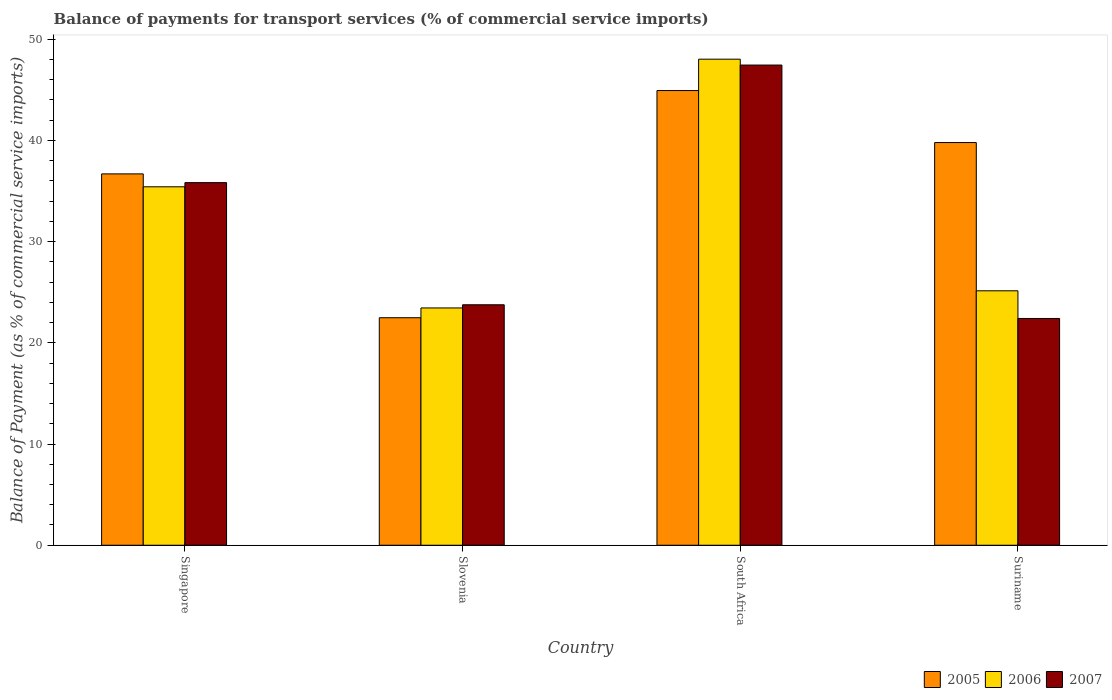How many different coloured bars are there?
Offer a terse response. 3. Are the number of bars per tick equal to the number of legend labels?
Provide a succinct answer. Yes. How many bars are there on the 1st tick from the left?
Your answer should be compact. 3. How many bars are there on the 4th tick from the right?
Provide a succinct answer. 3. What is the label of the 4th group of bars from the left?
Give a very brief answer. Suriname. What is the balance of payments for transport services in 2006 in South Africa?
Provide a short and direct response. 48.03. Across all countries, what is the maximum balance of payments for transport services in 2006?
Give a very brief answer. 48.03. Across all countries, what is the minimum balance of payments for transport services in 2006?
Give a very brief answer. 23.45. In which country was the balance of payments for transport services in 2007 maximum?
Your response must be concise. South Africa. In which country was the balance of payments for transport services in 2007 minimum?
Your answer should be compact. Suriname. What is the total balance of payments for transport services in 2006 in the graph?
Keep it short and to the point. 132.04. What is the difference between the balance of payments for transport services in 2007 in Slovenia and that in Suriname?
Give a very brief answer. 1.35. What is the difference between the balance of payments for transport services in 2006 in Suriname and the balance of payments for transport services in 2005 in Slovenia?
Offer a very short reply. 2.66. What is the average balance of payments for transport services in 2007 per country?
Make the answer very short. 32.36. What is the difference between the balance of payments for transport services of/in 2007 and balance of payments for transport services of/in 2006 in South Africa?
Give a very brief answer. -0.58. What is the ratio of the balance of payments for transport services in 2007 in Singapore to that in Slovenia?
Offer a very short reply. 1.51. Is the balance of payments for transport services in 2007 in South Africa less than that in Suriname?
Keep it short and to the point. No. What is the difference between the highest and the second highest balance of payments for transport services in 2006?
Your response must be concise. 22.89. What is the difference between the highest and the lowest balance of payments for transport services in 2005?
Provide a succinct answer. 22.45. In how many countries, is the balance of payments for transport services in 2005 greater than the average balance of payments for transport services in 2005 taken over all countries?
Your answer should be compact. 3. What does the 1st bar from the left in Suriname represents?
Ensure brevity in your answer.  2005. Is it the case that in every country, the sum of the balance of payments for transport services in 2005 and balance of payments for transport services in 2007 is greater than the balance of payments for transport services in 2006?
Your answer should be compact. Yes. Are the values on the major ticks of Y-axis written in scientific E-notation?
Your answer should be compact. No. Does the graph contain grids?
Keep it short and to the point. No. How many legend labels are there?
Make the answer very short. 3. What is the title of the graph?
Give a very brief answer. Balance of payments for transport services (% of commercial service imports). What is the label or title of the X-axis?
Your answer should be compact. Country. What is the label or title of the Y-axis?
Your answer should be compact. Balance of Payment (as % of commercial service imports). What is the Balance of Payment (as % of commercial service imports) in 2005 in Singapore?
Your answer should be very brief. 36.69. What is the Balance of Payment (as % of commercial service imports) in 2006 in Singapore?
Give a very brief answer. 35.42. What is the Balance of Payment (as % of commercial service imports) in 2007 in Singapore?
Your answer should be very brief. 35.83. What is the Balance of Payment (as % of commercial service imports) in 2005 in Slovenia?
Provide a short and direct response. 22.48. What is the Balance of Payment (as % of commercial service imports) of 2006 in Slovenia?
Your response must be concise. 23.45. What is the Balance of Payment (as % of commercial service imports) in 2007 in Slovenia?
Your response must be concise. 23.76. What is the Balance of Payment (as % of commercial service imports) in 2005 in South Africa?
Your answer should be compact. 44.93. What is the Balance of Payment (as % of commercial service imports) in 2006 in South Africa?
Give a very brief answer. 48.03. What is the Balance of Payment (as % of commercial service imports) in 2007 in South Africa?
Your answer should be compact. 47.45. What is the Balance of Payment (as % of commercial service imports) in 2005 in Suriname?
Your answer should be very brief. 39.79. What is the Balance of Payment (as % of commercial service imports) of 2006 in Suriname?
Provide a succinct answer. 25.14. What is the Balance of Payment (as % of commercial service imports) in 2007 in Suriname?
Ensure brevity in your answer.  22.41. Across all countries, what is the maximum Balance of Payment (as % of commercial service imports) of 2005?
Keep it short and to the point. 44.93. Across all countries, what is the maximum Balance of Payment (as % of commercial service imports) of 2006?
Provide a short and direct response. 48.03. Across all countries, what is the maximum Balance of Payment (as % of commercial service imports) in 2007?
Provide a succinct answer. 47.45. Across all countries, what is the minimum Balance of Payment (as % of commercial service imports) of 2005?
Ensure brevity in your answer.  22.48. Across all countries, what is the minimum Balance of Payment (as % of commercial service imports) in 2006?
Provide a succinct answer. 23.45. Across all countries, what is the minimum Balance of Payment (as % of commercial service imports) in 2007?
Ensure brevity in your answer.  22.41. What is the total Balance of Payment (as % of commercial service imports) of 2005 in the graph?
Provide a succinct answer. 143.89. What is the total Balance of Payment (as % of commercial service imports) of 2006 in the graph?
Your response must be concise. 132.04. What is the total Balance of Payment (as % of commercial service imports) in 2007 in the graph?
Offer a very short reply. 129.45. What is the difference between the Balance of Payment (as % of commercial service imports) in 2005 in Singapore and that in Slovenia?
Offer a very short reply. 14.21. What is the difference between the Balance of Payment (as % of commercial service imports) in 2006 in Singapore and that in Slovenia?
Your response must be concise. 11.97. What is the difference between the Balance of Payment (as % of commercial service imports) of 2007 in Singapore and that in Slovenia?
Your response must be concise. 12.07. What is the difference between the Balance of Payment (as % of commercial service imports) in 2005 in Singapore and that in South Africa?
Offer a terse response. -8.23. What is the difference between the Balance of Payment (as % of commercial service imports) of 2006 in Singapore and that in South Africa?
Offer a very short reply. -12.61. What is the difference between the Balance of Payment (as % of commercial service imports) in 2007 in Singapore and that in South Africa?
Your answer should be very brief. -11.62. What is the difference between the Balance of Payment (as % of commercial service imports) of 2005 in Singapore and that in Suriname?
Your answer should be compact. -3.1. What is the difference between the Balance of Payment (as % of commercial service imports) of 2006 in Singapore and that in Suriname?
Your answer should be very brief. 10.28. What is the difference between the Balance of Payment (as % of commercial service imports) in 2007 in Singapore and that in Suriname?
Offer a terse response. 13.42. What is the difference between the Balance of Payment (as % of commercial service imports) in 2005 in Slovenia and that in South Africa?
Provide a short and direct response. -22.45. What is the difference between the Balance of Payment (as % of commercial service imports) of 2006 in Slovenia and that in South Africa?
Your answer should be very brief. -24.58. What is the difference between the Balance of Payment (as % of commercial service imports) in 2007 in Slovenia and that in South Africa?
Provide a short and direct response. -23.69. What is the difference between the Balance of Payment (as % of commercial service imports) in 2005 in Slovenia and that in Suriname?
Give a very brief answer. -17.31. What is the difference between the Balance of Payment (as % of commercial service imports) in 2006 in Slovenia and that in Suriname?
Provide a succinct answer. -1.69. What is the difference between the Balance of Payment (as % of commercial service imports) of 2007 in Slovenia and that in Suriname?
Ensure brevity in your answer.  1.35. What is the difference between the Balance of Payment (as % of commercial service imports) of 2005 in South Africa and that in Suriname?
Your response must be concise. 5.14. What is the difference between the Balance of Payment (as % of commercial service imports) of 2006 in South Africa and that in Suriname?
Provide a succinct answer. 22.89. What is the difference between the Balance of Payment (as % of commercial service imports) of 2007 in South Africa and that in Suriname?
Ensure brevity in your answer.  25.04. What is the difference between the Balance of Payment (as % of commercial service imports) of 2005 in Singapore and the Balance of Payment (as % of commercial service imports) of 2006 in Slovenia?
Ensure brevity in your answer.  13.25. What is the difference between the Balance of Payment (as % of commercial service imports) in 2005 in Singapore and the Balance of Payment (as % of commercial service imports) in 2007 in Slovenia?
Your answer should be very brief. 12.93. What is the difference between the Balance of Payment (as % of commercial service imports) in 2006 in Singapore and the Balance of Payment (as % of commercial service imports) in 2007 in Slovenia?
Give a very brief answer. 11.66. What is the difference between the Balance of Payment (as % of commercial service imports) of 2005 in Singapore and the Balance of Payment (as % of commercial service imports) of 2006 in South Africa?
Make the answer very short. -11.34. What is the difference between the Balance of Payment (as % of commercial service imports) of 2005 in Singapore and the Balance of Payment (as % of commercial service imports) of 2007 in South Africa?
Keep it short and to the point. -10.75. What is the difference between the Balance of Payment (as % of commercial service imports) of 2006 in Singapore and the Balance of Payment (as % of commercial service imports) of 2007 in South Africa?
Make the answer very short. -12.03. What is the difference between the Balance of Payment (as % of commercial service imports) of 2005 in Singapore and the Balance of Payment (as % of commercial service imports) of 2006 in Suriname?
Ensure brevity in your answer.  11.55. What is the difference between the Balance of Payment (as % of commercial service imports) in 2005 in Singapore and the Balance of Payment (as % of commercial service imports) in 2007 in Suriname?
Your answer should be compact. 14.29. What is the difference between the Balance of Payment (as % of commercial service imports) of 2006 in Singapore and the Balance of Payment (as % of commercial service imports) of 2007 in Suriname?
Ensure brevity in your answer.  13.01. What is the difference between the Balance of Payment (as % of commercial service imports) of 2005 in Slovenia and the Balance of Payment (as % of commercial service imports) of 2006 in South Africa?
Offer a terse response. -25.55. What is the difference between the Balance of Payment (as % of commercial service imports) of 2005 in Slovenia and the Balance of Payment (as % of commercial service imports) of 2007 in South Africa?
Offer a very short reply. -24.97. What is the difference between the Balance of Payment (as % of commercial service imports) in 2006 in Slovenia and the Balance of Payment (as % of commercial service imports) in 2007 in South Africa?
Your response must be concise. -24. What is the difference between the Balance of Payment (as % of commercial service imports) in 2005 in Slovenia and the Balance of Payment (as % of commercial service imports) in 2006 in Suriname?
Your answer should be very brief. -2.66. What is the difference between the Balance of Payment (as % of commercial service imports) in 2005 in Slovenia and the Balance of Payment (as % of commercial service imports) in 2007 in Suriname?
Offer a terse response. 0.07. What is the difference between the Balance of Payment (as % of commercial service imports) of 2006 in Slovenia and the Balance of Payment (as % of commercial service imports) of 2007 in Suriname?
Your response must be concise. 1.04. What is the difference between the Balance of Payment (as % of commercial service imports) of 2005 in South Africa and the Balance of Payment (as % of commercial service imports) of 2006 in Suriname?
Give a very brief answer. 19.79. What is the difference between the Balance of Payment (as % of commercial service imports) of 2005 in South Africa and the Balance of Payment (as % of commercial service imports) of 2007 in Suriname?
Your answer should be compact. 22.52. What is the difference between the Balance of Payment (as % of commercial service imports) in 2006 in South Africa and the Balance of Payment (as % of commercial service imports) in 2007 in Suriname?
Offer a very short reply. 25.62. What is the average Balance of Payment (as % of commercial service imports) of 2005 per country?
Provide a short and direct response. 35.97. What is the average Balance of Payment (as % of commercial service imports) of 2006 per country?
Keep it short and to the point. 33.01. What is the average Balance of Payment (as % of commercial service imports) of 2007 per country?
Provide a succinct answer. 32.36. What is the difference between the Balance of Payment (as % of commercial service imports) in 2005 and Balance of Payment (as % of commercial service imports) in 2006 in Singapore?
Keep it short and to the point. 1.28. What is the difference between the Balance of Payment (as % of commercial service imports) of 2005 and Balance of Payment (as % of commercial service imports) of 2007 in Singapore?
Your response must be concise. 0.86. What is the difference between the Balance of Payment (as % of commercial service imports) of 2006 and Balance of Payment (as % of commercial service imports) of 2007 in Singapore?
Your response must be concise. -0.41. What is the difference between the Balance of Payment (as % of commercial service imports) of 2005 and Balance of Payment (as % of commercial service imports) of 2006 in Slovenia?
Make the answer very short. -0.97. What is the difference between the Balance of Payment (as % of commercial service imports) in 2005 and Balance of Payment (as % of commercial service imports) in 2007 in Slovenia?
Your answer should be compact. -1.28. What is the difference between the Balance of Payment (as % of commercial service imports) in 2006 and Balance of Payment (as % of commercial service imports) in 2007 in Slovenia?
Offer a very short reply. -0.31. What is the difference between the Balance of Payment (as % of commercial service imports) of 2005 and Balance of Payment (as % of commercial service imports) of 2006 in South Africa?
Offer a very short reply. -3.1. What is the difference between the Balance of Payment (as % of commercial service imports) of 2005 and Balance of Payment (as % of commercial service imports) of 2007 in South Africa?
Offer a terse response. -2.52. What is the difference between the Balance of Payment (as % of commercial service imports) of 2006 and Balance of Payment (as % of commercial service imports) of 2007 in South Africa?
Your answer should be compact. 0.58. What is the difference between the Balance of Payment (as % of commercial service imports) of 2005 and Balance of Payment (as % of commercial service imports) of 2006 in Suriname?
Offer a very short reply. 14.65. What is the difference between the Balance of Payment (as % of commercial service imports) in 2005 and Balance of Payment (as % of commercial service imports) in 2007 in Suriname?
Ensure brevity in your answer.  17.38. What is the difference between the Balance of Payment (as % of commercial service imports) in 2006 and Balance of Payment (as % of commercial service imports) in 2007 in Suriname?
Provide a short and direct response. 2.73. What is the ratio of the Balance of Payment (as % of commercial service imports) in 2005 in Singapore to that in Slovenia?
Offer a very short reply. 1.63. What is the ratio of the Balance of Payment (as % of commercial service imports) of 2006 in Singapore to that in Slovenia?
Your answer should be compact. 1.51. What is the ratio of the Balance of Payment (as % of commercial service imports) in 2007 in Singapore to that in Slovenia?
Keep it short and to the point. 1.51. What is the ratio of the Balance of Payment (as % of commercial service imports) of 2005 in Singapore to that in South Africa?
Offer a very short reply. 0.82. What is the ratio of the Balance of Payment (as % of commercial service imports) in 2006 in Singapore to that in South Africa?
Your answer should be very brief. 0.74. What is the ratio of the Balance of Payment (as % of commercial service imports) of 2007 in Singapore to that in South Africa?
Offer a terse response. 0.76. What is the ratio of the Balance of Payment (as % of commercial service imports) in 2005 in Singapore to that in Suriname?
Your answer should be very brief. 0.92. What is the ratio of the Balance of Payment (as % of commercial service imports) of 2006 in Singapore to that in Suriname?
Provide a succinct answer. 1.41. What is the ratio of the Balance of Payment (as % of commercial service imports) of 2007 in Singapore to that in Suriname?
Your answer should be very brief. 1.6. What is the ratio of the Balance of Payment (as % of commercial service imports) in 2005 in Slovenia to that in South Africa?
Ensure brevity in your answer.  0.5. What is the ratio of the Balance of Payment (as % of commercial service imports) of 2006 in Slovenia to that in South Africa?
Your response must be concise. 0.49. What is the ratio of the Balance of Payment (as % of commercial service imports) of 2007 in Slovenia to that in South Africa?
Provide a succinct answer. 0.5. What is the ratio of the Balance of Payment (as % of commercial service imports) of 2005 in Slovenia to that in Suriname?
Give a very brief answer. 0.56. What is the ratio of the Balance of Payment (as % of commercial service imports) of 2006 in Slovenia to that in Suriname?
Keep it short and to the point. 0.93. What is the ratio of the Balance of Payment (as % of commercial service imports) in 2007 in Slovenia to that in Suriname?
Provide a short and direct response. 1.06. What is the ratio of the Balance of Payment (as % of commercial service imports) of 2005 in South Africa to that in Suriname?
Provide a succinct answer. 1.13. What is the ratio of the Balance of Payment (as % of commercial service imports) in 2006 in South Africa to that in Suriname?
Your response must be concise. 1.91. What is the ratio of the Balance of Payment (as % of commercial service imports) in 2007 in South Africa to that in Suriname?
Keep it short and to the point. 2.12. What is the difference between the highest and the second highest Balance of Payment (as % of commercial service imports) in 2005?
Your answer should be very brief. 5.14. What is the difference between the highest and the second highest Balance of Payment (as % of commercial service imports) of 2006?
Provide a succinct answer. 12.61. What is the difference between the highest and the second highest Balance of Payment (as % of commercial service imports) of 2007?
Your answer should be compact. 11.62. What is the difference between the highest and the lowest Balance of Payment (as % of commercial service imports) of 2005?
Your answer should be compact. 22.45. What is the difference between the highest and the lowest Balance of Payment (as % of commercial service imports) of 2006?
Your answer should be compact. 24.58. What is the difference between the highest and the lowest Balance of Payment (as % of commercial service imports) in 2007?
Offer a terse response. 25.04. 